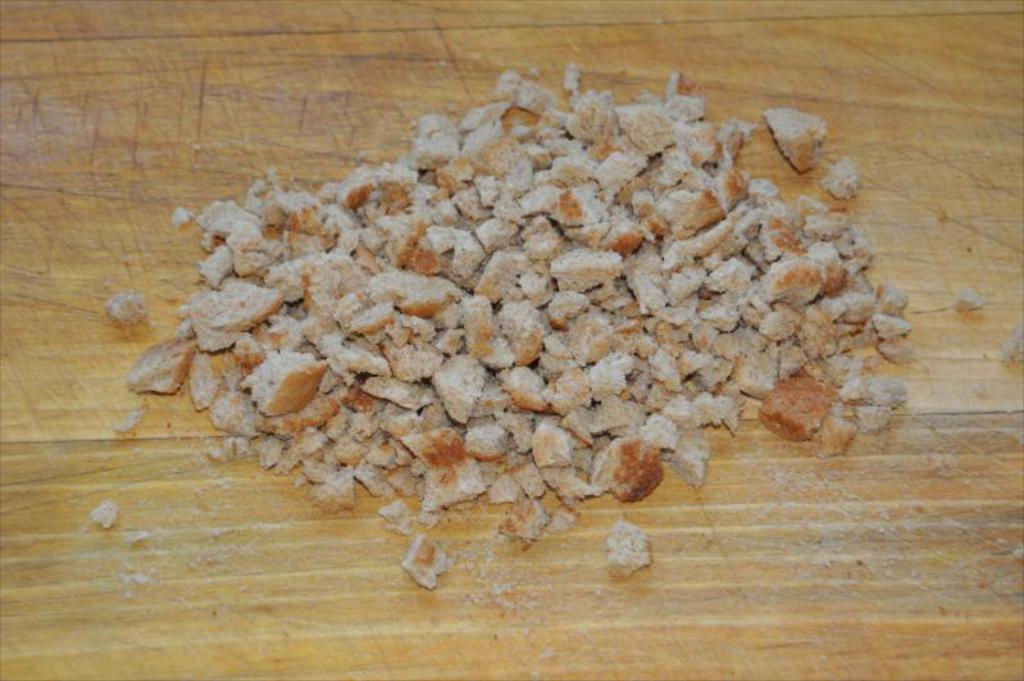What type of surface is visible in the image? There is a wooden surface in the image. What is on top of the wooden surface? There are small pieces of bread on the wooden surface. What level of the building is the wooden surface located on in the image? There is no information about the building or its levels in the image, as it only shows a wooden surface with small pieces of bread on it. 